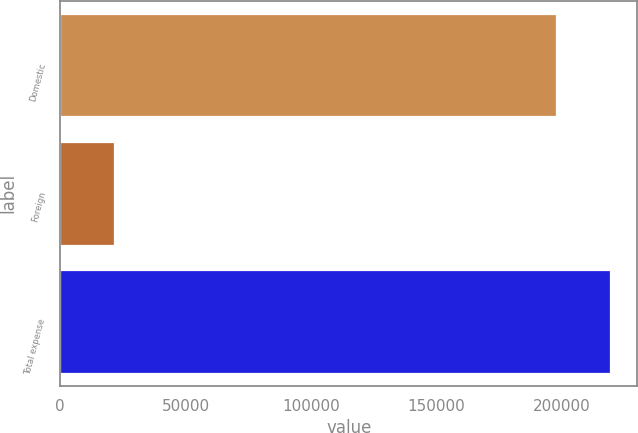Convert chart to OTSL. <chart><loc_0><loc_0><loc_500><loc_500><bar_chart><fcel>Domestic<fcel>Foreign<fcel>Total expense<nl><fcel>198093<fcel>21340<fcel>219433<nl></chart> 